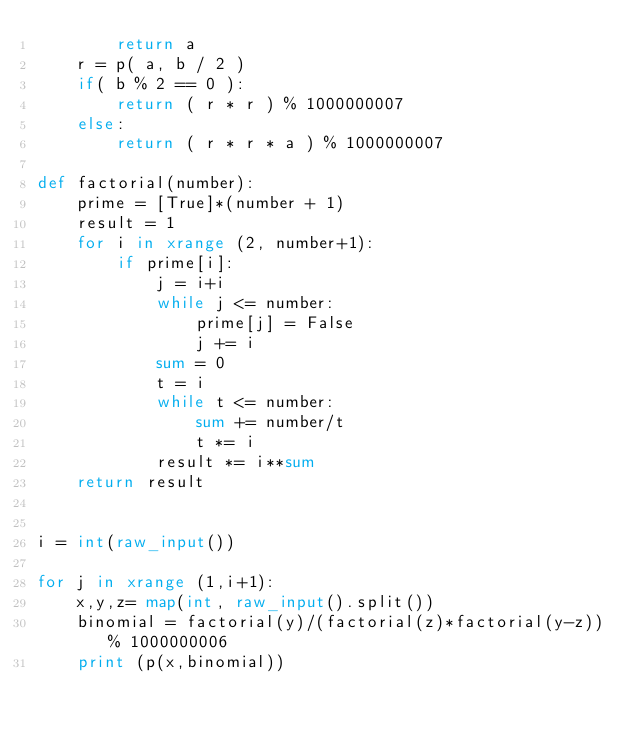Convert code to text. <code><loc_0><loc_0><loc_500><loc_500><_Python_>        return a
    r = p( a, b / 2 )
    if( b % 2 == 0 ):
        return ( r * r ) % 1000000007
    else:
        return ( r * r * a ) % 1000000007

def factorial(number):
    prime = [True]*(number + 1)
    result = 1
    for i in xrange (2, number+1):
        if prime[i]:
            j = i+i
            while j <= number:
                prime[j] = False
                j += i
            sum = 0
            t = i
            while t <= number:
                sum += number/t
                t *= i
            result *= i**sum
    return result
      
      
i = int(raw_input())

for j in xrange (1,i+1):
    x,y,z= map(int, raw_input().split())
    binomial = factorial(y)/(factorial(z)*factorial(y-z))% 1000000006
    print (p(x,binomial))</code> 